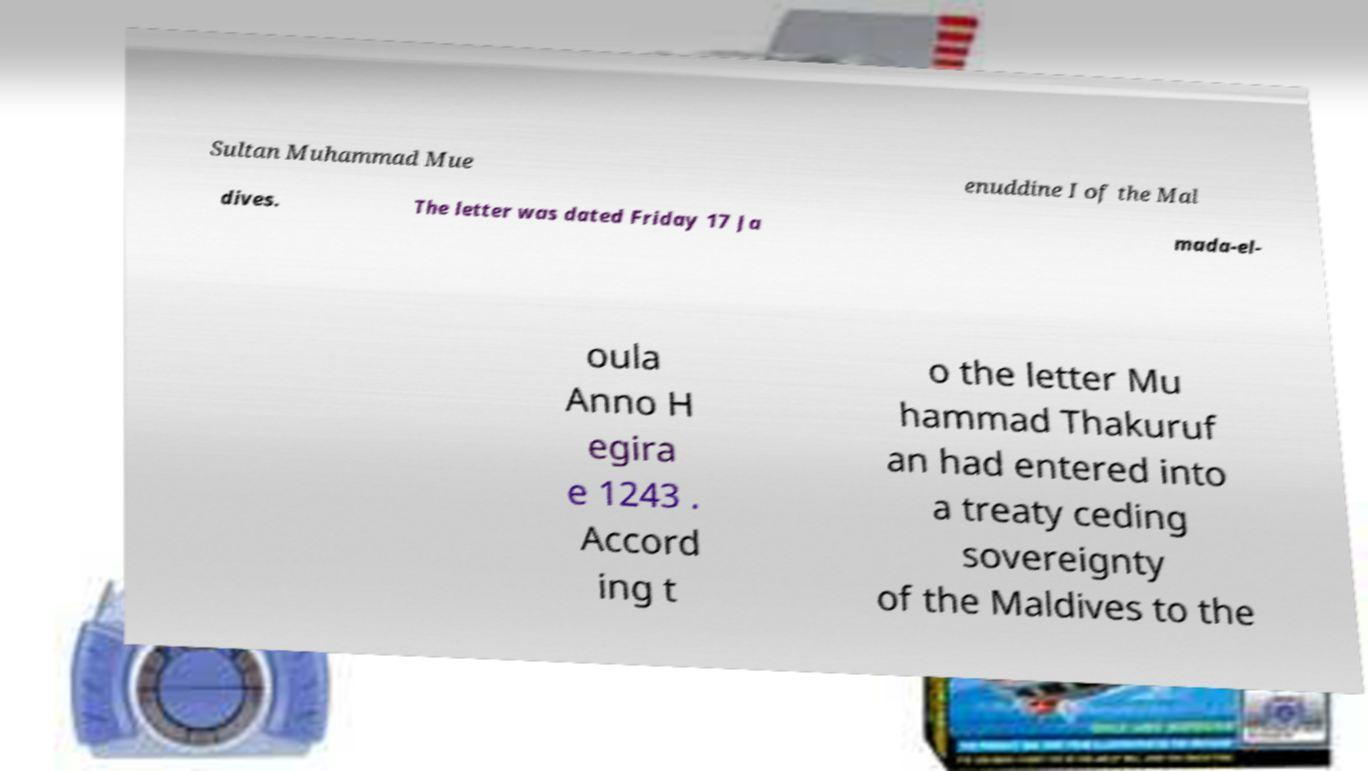Can you read and provide the text displayed in the image?This photo seems to have some interesting text. Can you extract and type it out for me? Sultan Muhammad Mue enuddine I of the Mal dives. The letter was dated Friday 17 Ja mada-el- oula Anno H egira e 1243 . Accord ing t o the letter Mu hammad Thakuruf an had entered into a treaty ceding sovereignty of the Maldives to the 